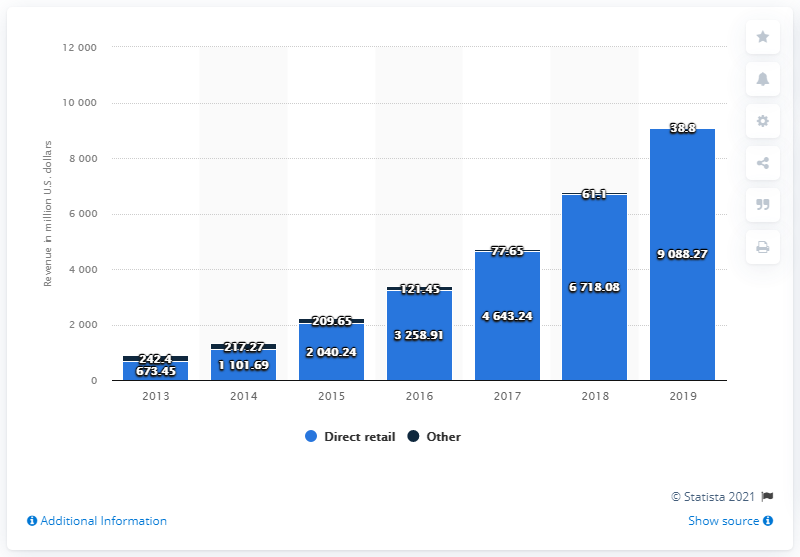Outline some significant characteristics in this image. In 2019, Wayfair generated 9088.27 direct retail sales in revenue. 